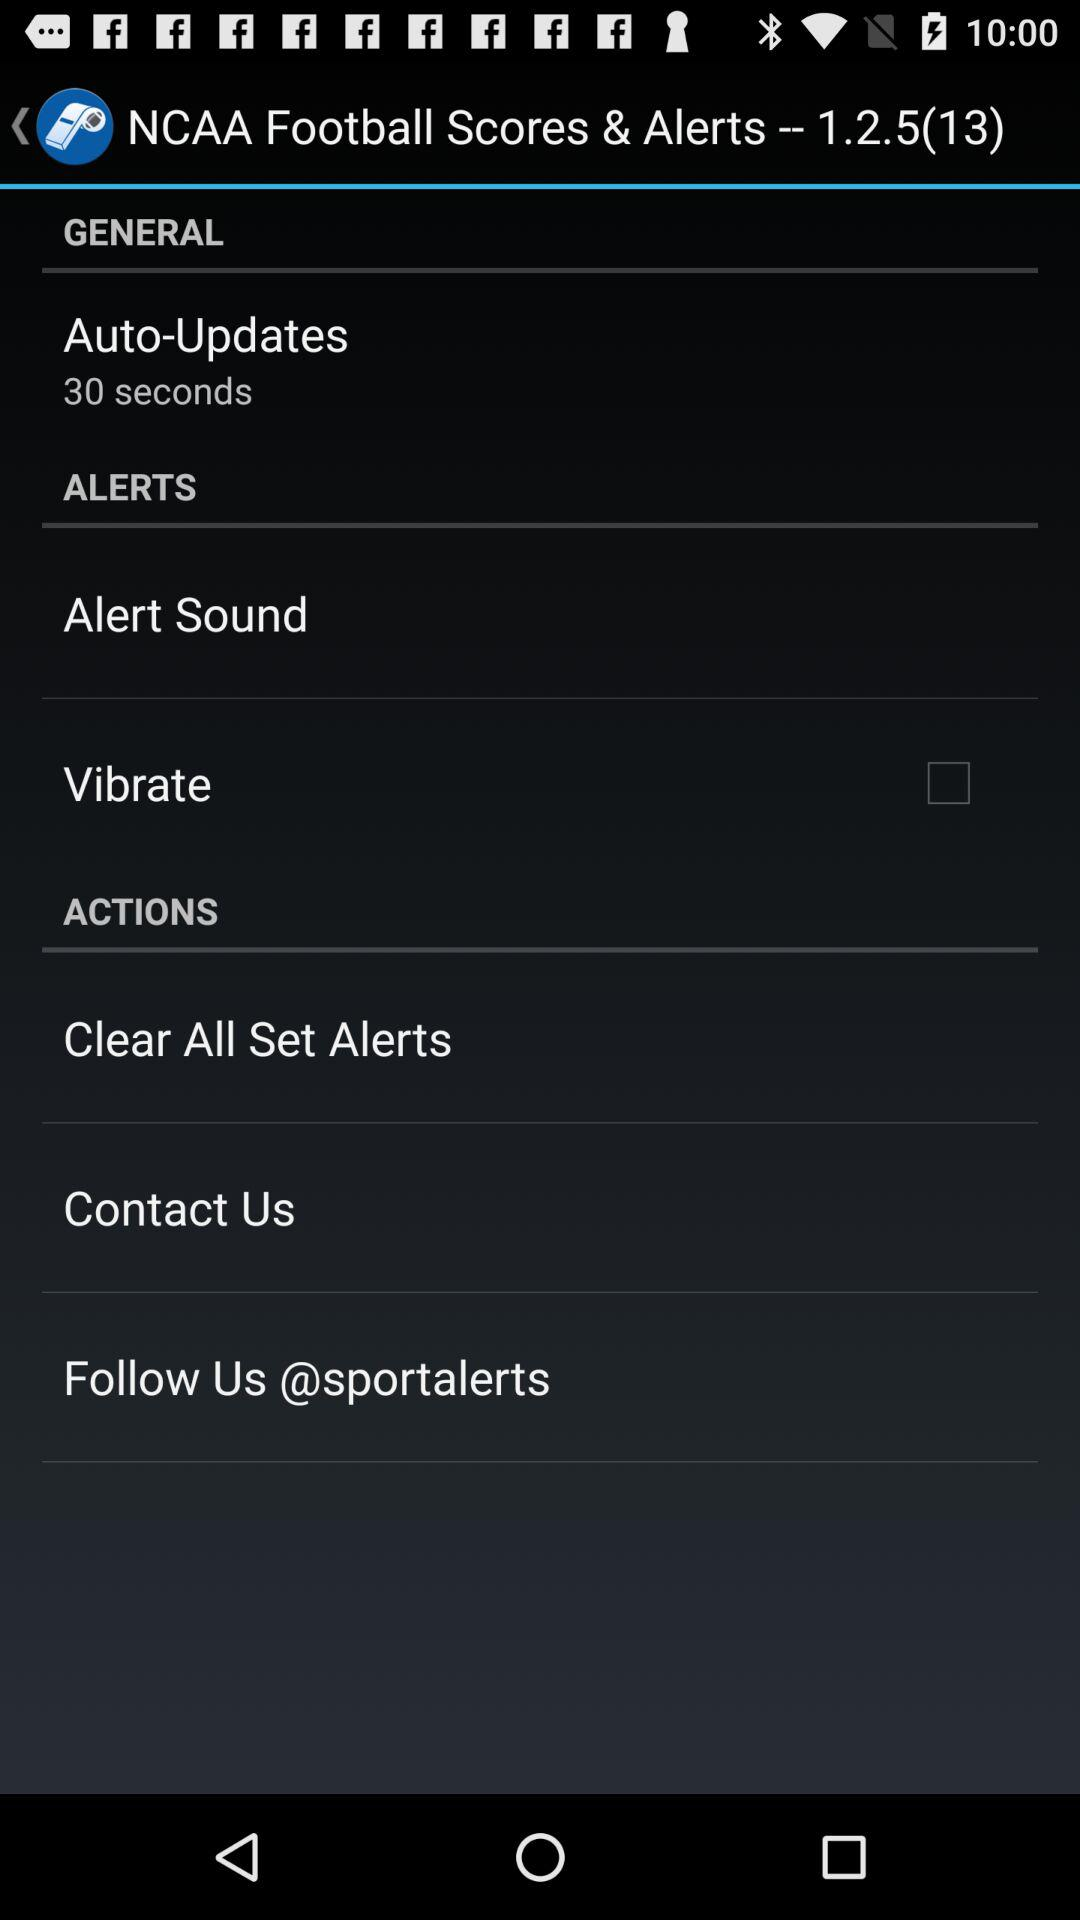Where can we follow "NCAA Football Scores & Alerts"? You can follow "NCAA Football Scores & Alerts" at "@sportalerts". 